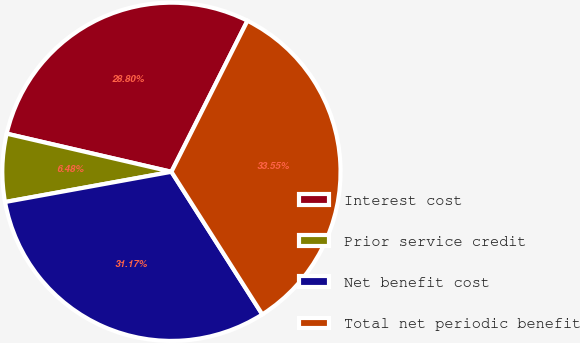Convert chart. <chart><loc_0><loc_0><loc_500><loc_500><pie_chart><fcel>Interest cost<fcel>Prior service credit<fcel>Net benefit cost<fcel>Total net periodic benefit<nl><fcel>28.8%<fcel>6.48%<fcel>31.17%<fcel>33.55%<nl></chart> 